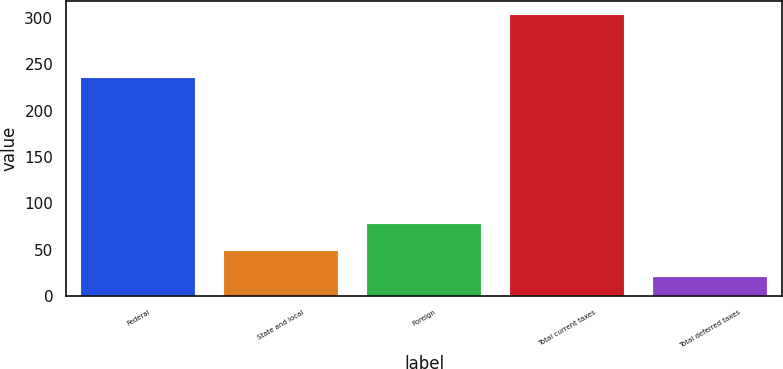Convert chart to OTSL. <chart><loc_0><loc_0><loc_500><loc_500><bar_chart><fcel>Federal<fcel>State and local<fcel>Foreign<fcel>Total current taxes<fcel>Total deferred taxes<nl><fcel>235.8<fcel>49.17<fcel>77.44<fcel>303.6<fcel>20.9<nl></chart> 